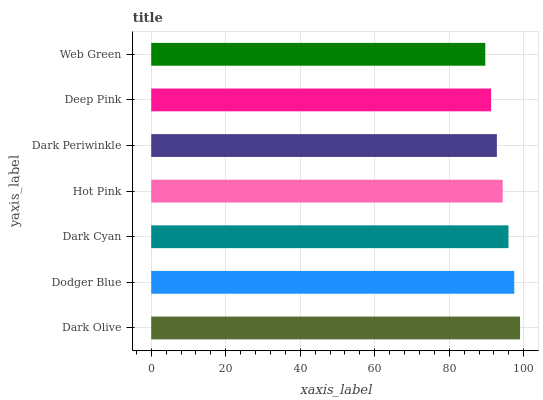Is Web Green the minimum?
Answer yes or no. Yes. Is Dark Olive the maximum?
Answer yes or no. Yes. Is Dodger Blue the minimum?
Answer yes or no. No. Is Dodger Blue the maximum?
Answer yes or no. No. Is Dark Olive greater than Dodger Blue?
Answer yes or no. Yes. Is Dodger Blue less than Dark Olive?
Answer yes or no. Yes. Is Dodger Blue greater than Dark Olive?
Answer yes or no. No. Is Dark Olive less than Dodger Blue?
Answer yes or no. No. Is Hot Pink the high median?
Answer yes or no. Yes. Is Hot Pink the low median?
Answer yes or no. Yes. Is Dark Olive the high median?
Answer yes or no. No. Is Web Green the low median?
Answer yes or no. No. 